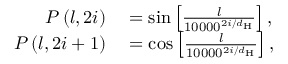Convert formula to latex. <formula><loc_0><loc_0><loc_500><loc_500>\begin{array} { r l } { P \left ( l , 2 i \right ) } & = \sin \left [ \frac { l } { 1 0 0 0 0 ^ { 2 i / d _ { H } } } \right ] , } \\ { P \left ( l , 2 i + 1 \right ) } & = \cos \left [ \frac { l } { 1 0 0 0 0 ^ { 2 i / d _ { H } } } \right ] , } \end{array}</formula> 